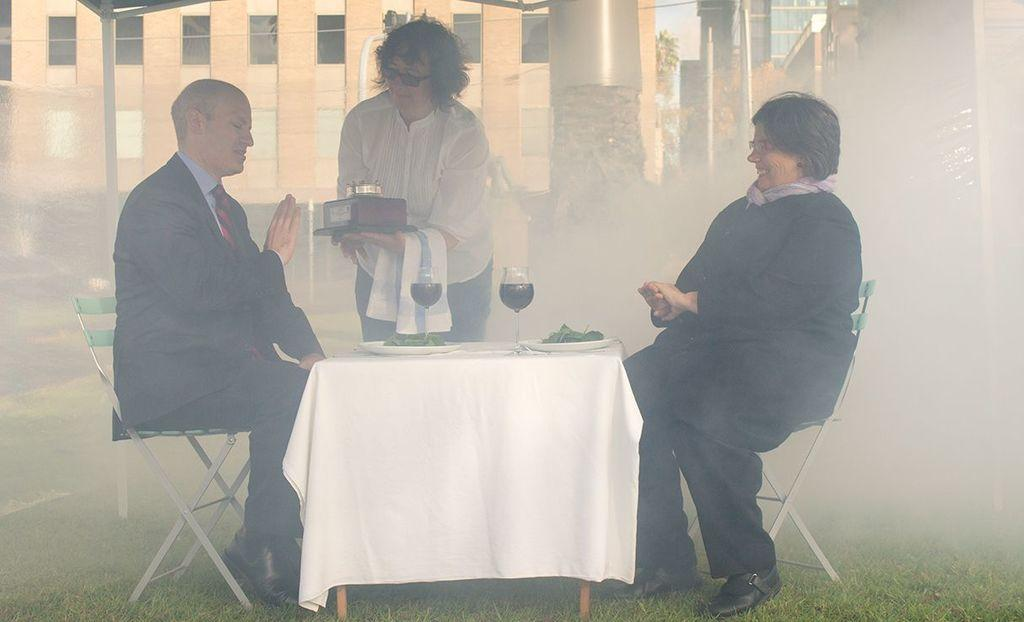How many people are present in the image? There are three people in the image. What are two of the people doing in the image? Two of the people are sitting in front of a table. What items can be seen on the table? There are plates and glasses on the table. What can be seen in the background of the image? There is a building visible in the background. What year is depicted in the image? The image does not depict a specific year; it is a snapshot of a scene with people, a table, and a building in the background. Can you see a drum on the table in the image? No, there is no drum present on the table in the image. 